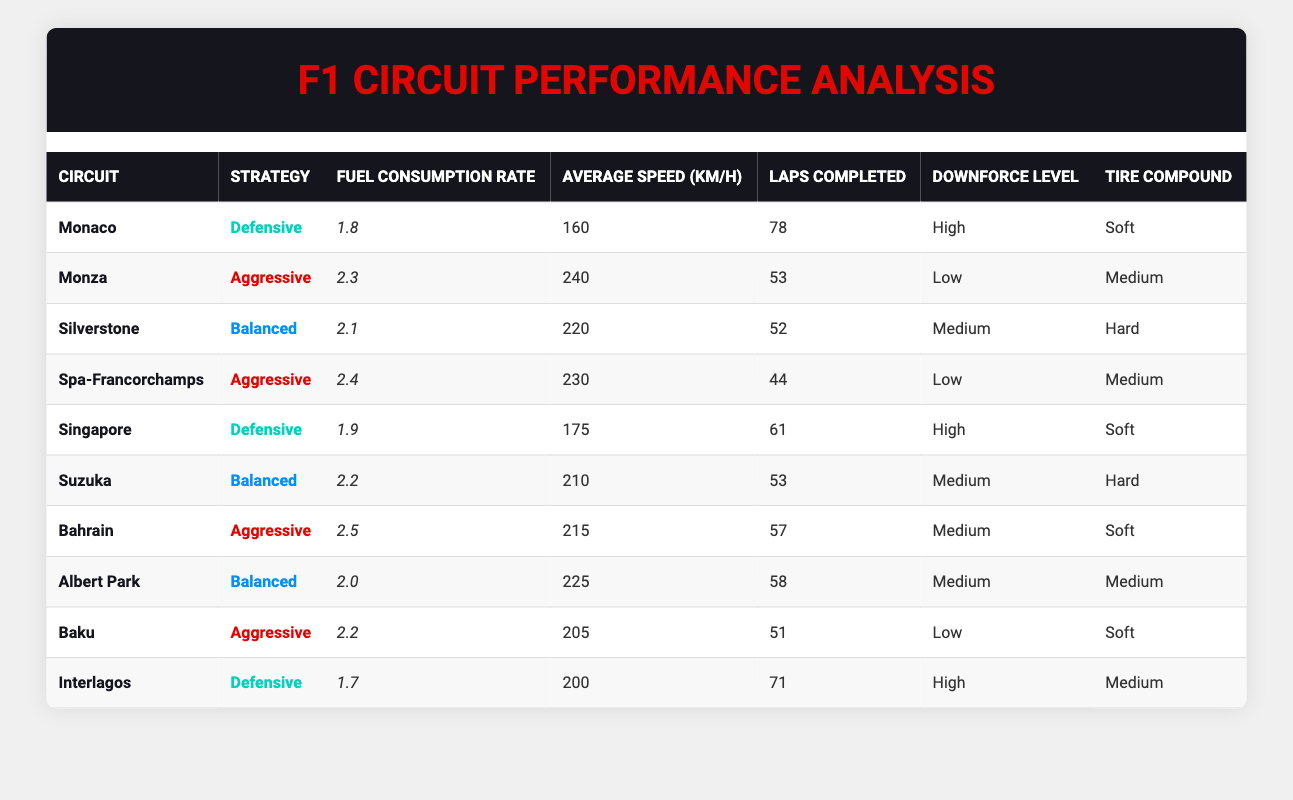What is the fuel consumption rate for Monaco using a defensive strategy? The table lists the fuel consumption rate for Monaco under the defensive strategy as 1.8.
Answer: 1.8 Which circuit has the highest average speed with an aggressive strategy? By examining the table, Spa-Francorchamps has the highest average speed of 230 km/h with the aggressive strategy.
Answer: Spa-Francorchamps What is the average fuel consumption rate of all the circuits using a balanced strategy? The fuel consumption rates under the balanced strategy are: 2.1 (Silverstone), 2.2 (Suzuka), and 2.0 (Albert Park). Summing these gives 2.1 + 2.2 + 2.0 = 6.3, and dividing by 3 gives an average of 2.1.
Answer: 2.1 Is the average speed of defensive strategy circuits greater than 190 km/h? The average speeds for circuits using defensive strategies are: 160 (Monaco), 175 (Singapore), and 200 (Interlagos). Calculating the average gives (160 + 175 + 200)/3 = 178.33, which is less than 190 km/h.
Answer: No Which strategy leads to the lowest fuel consumption rate? By reviewing the table, the defensive strategy has a minimum fuel consumption rate of 1.7 (Interlagos) compared to all other strategies.
Answer: Defensive strategy How many laps were completed in total across all balanced strategy circuits? The table shows completed laps for balanced strategy: 52 (Silverstone), 53 (Suzuka), and 58 (Albert Park). Adding these gives 52 + 53 + 58 = 163 laps completed in total.
Answer: 163 Which circuit has the lowest fuel consumption rate and what strategy was used? The lowest fuel consumption rate is 1.7, which is recorded for Interlagos under a defensive strategy.
Answer: Interlagos with defensive strategy Do all aggressive strategies have a fuel consumption rate of over 2.0? Checking the aggressive strategy circuits, Monza (2.3), Spa-Francorchamps (2.4), Bahrain (2.5), and Baku (2.2) all show rates above 2.0, confirming the statement is true.
Answer: Yes What is the total number of laps completed at circuits with low downforce levels? The circuits with low downforce levels are Monza (53 laps), Spa-Francorchamps (44 laps), and Baku (51 laps). Adding these gives a total of 53 + 44 + 51 = 148 laps.
Answer: 148 